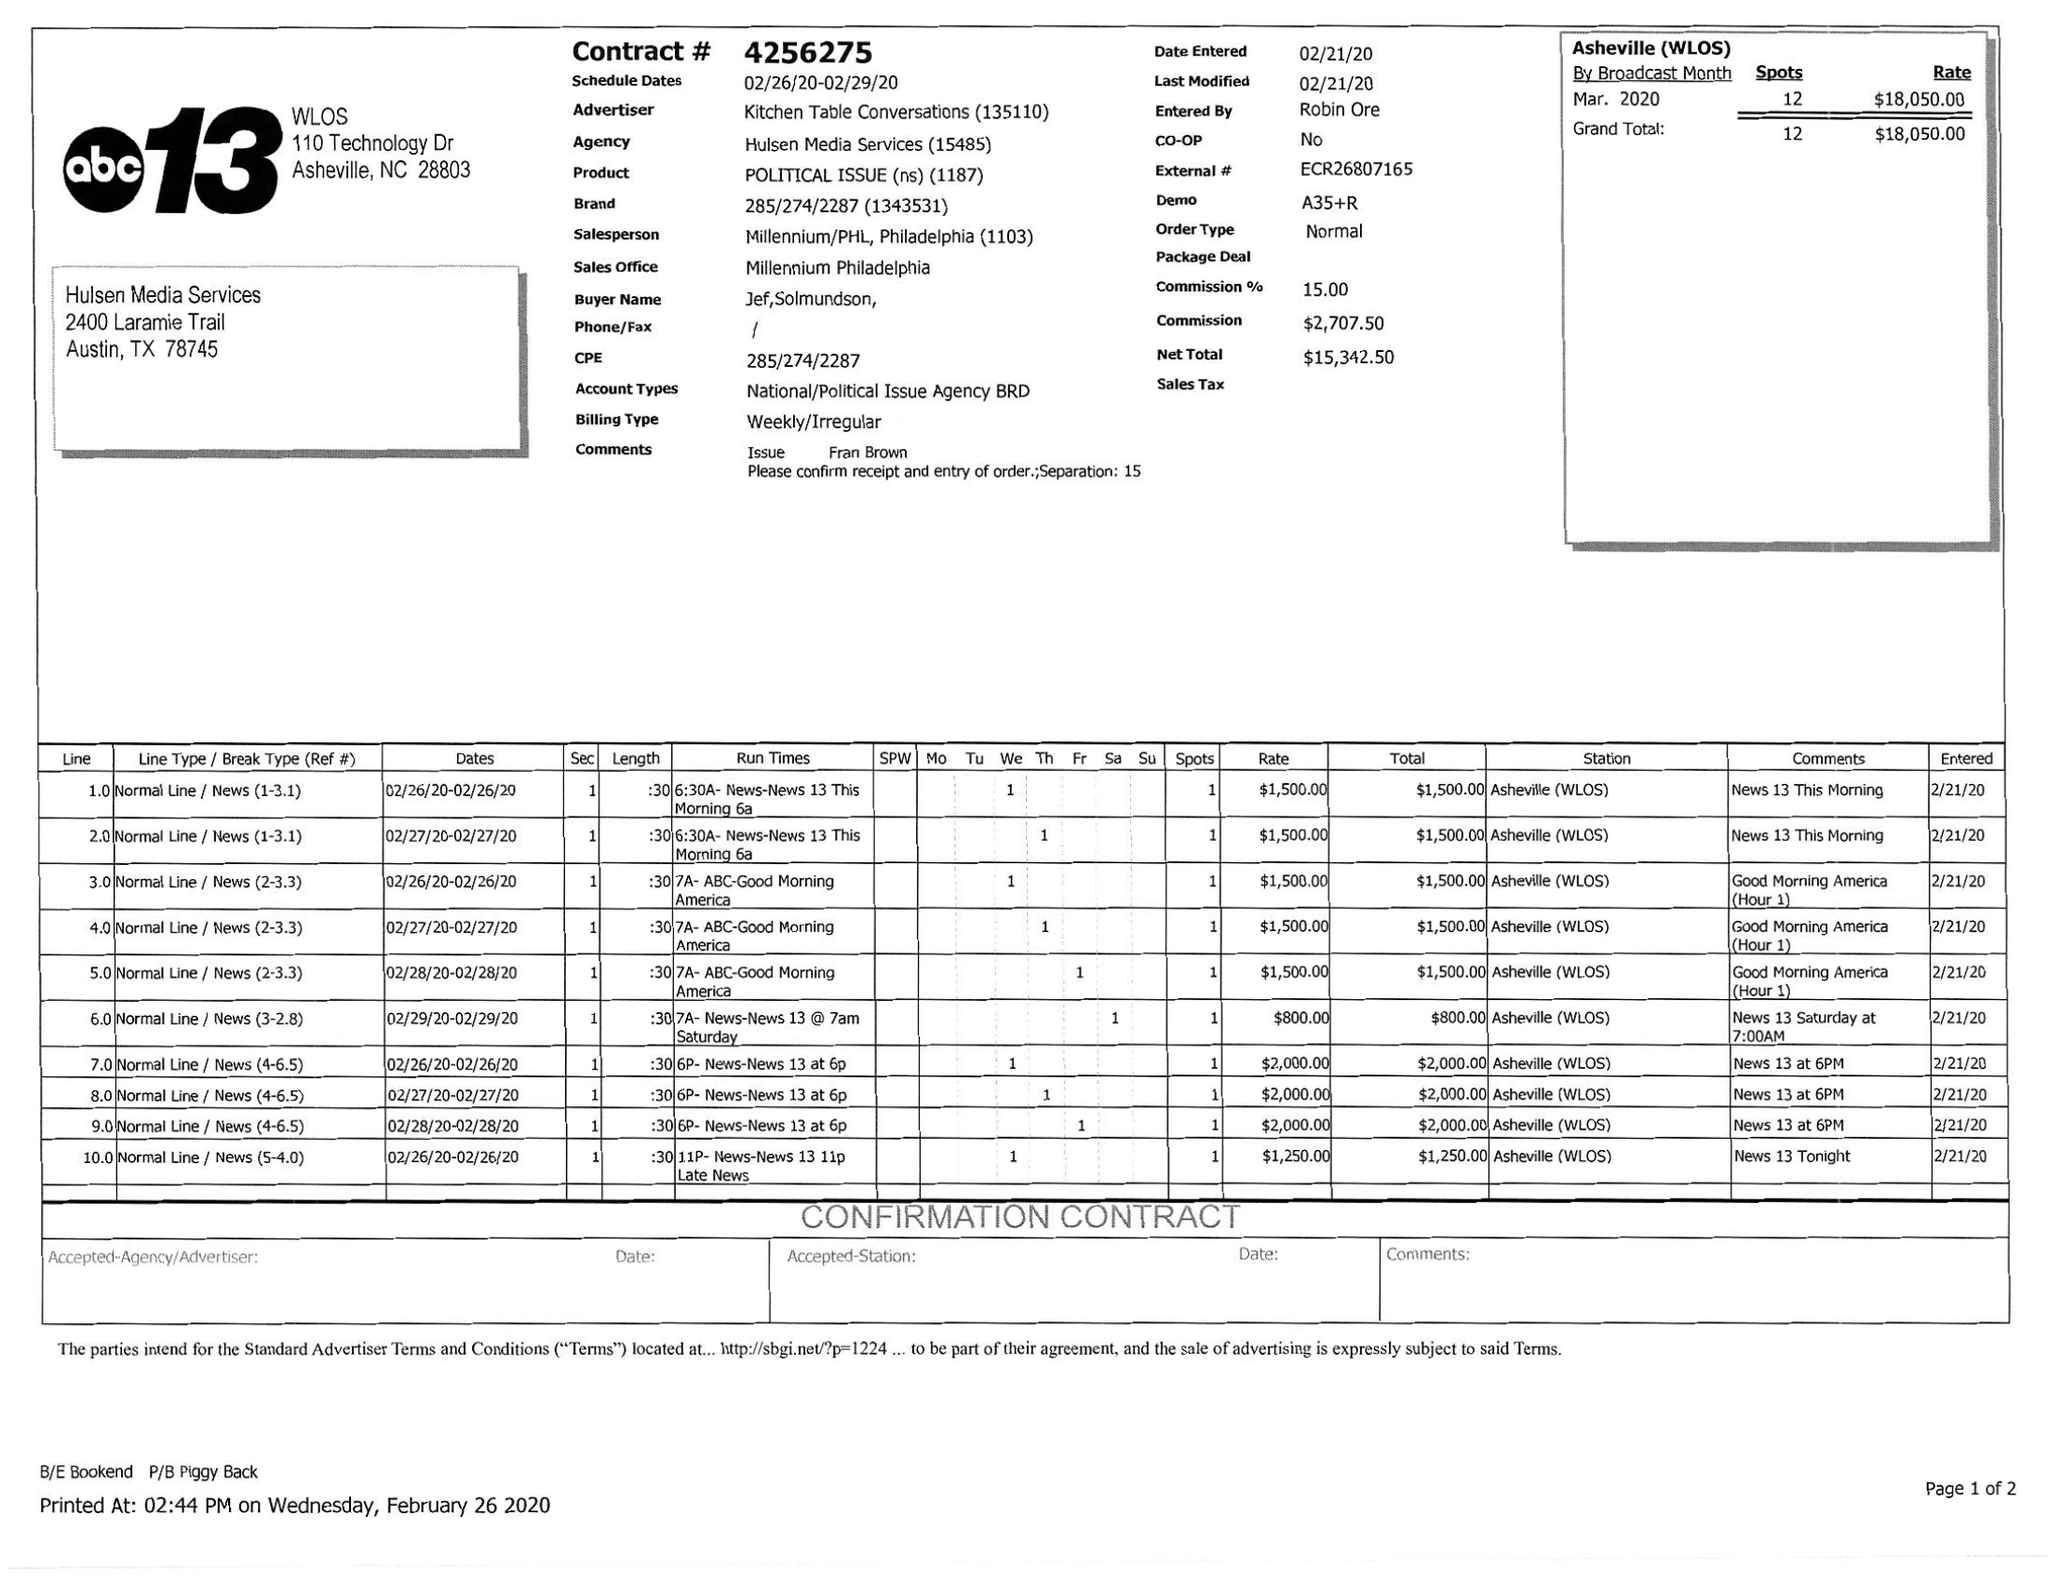What is the value for the flight_from?
Answer the question using a single word or phrase. 02/26/20 